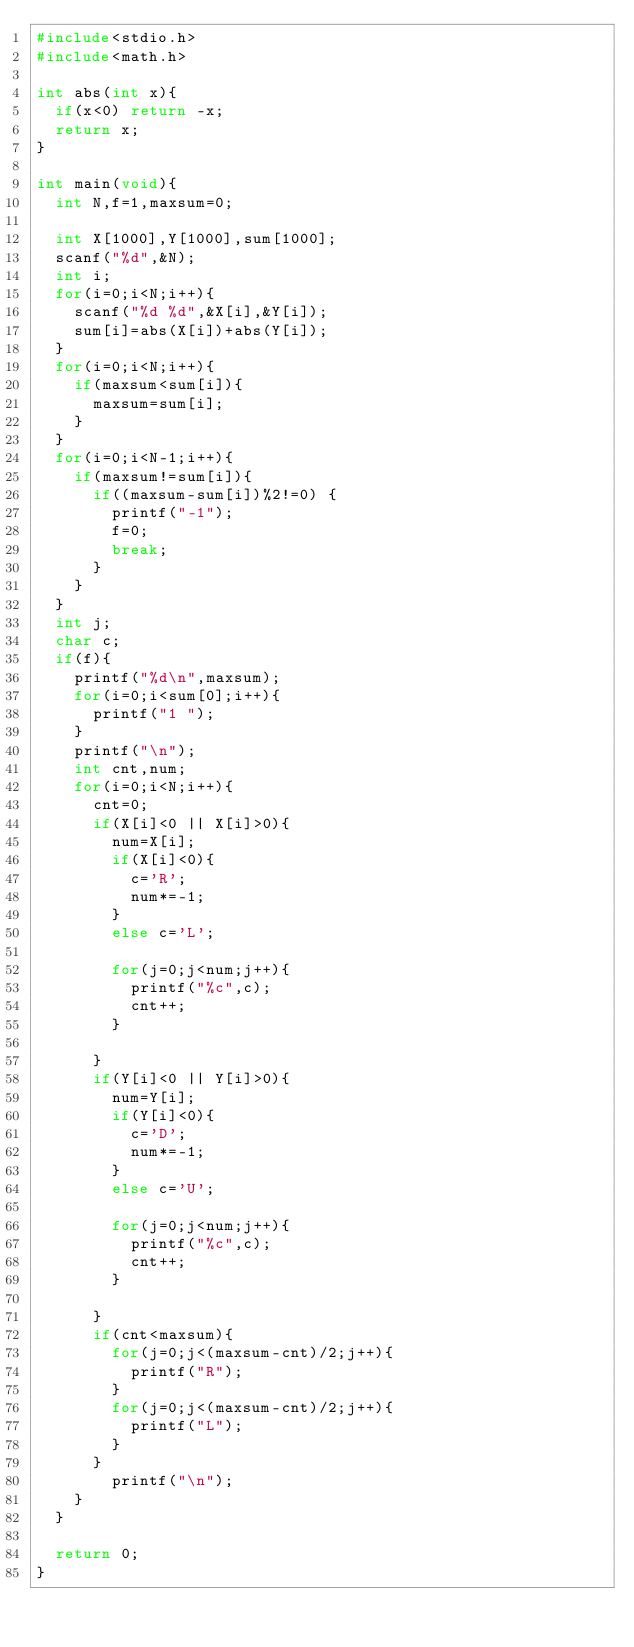<code> <loc_0><loc_0><loc_500><loc_500><_C_>#include<stdio.h>
#include<math.h>

int abs(int x){
  if(x<0) return -x;
  return x;
}

int main(void){
  int N,f=1,maxsum=0;

  int X[1000],Y[1000],sum[1000];
  scanf("%d",&N);
  int i;
  for(i=0;i<N;i++){
    scanf("%d %d",&X[i],&Y[i]);
    sum[i]=abs(X[i])+abs(Y[i]);
  }
  for(i=0;i<N;i++){
    if(maxsum<sum[i]){
      maxsum=sum[i];
    }
  }
  for(i=0;i<N-1;i++){
    if(maxsum!=sum[i]){
      if((maxsum-sum[i])%2!=0) {
        printf("-1");
        f=0;
        break;
      }
    }
  }
  int j;
  char c;
  if(f){
    printf("%d\n",maxsum);
    for(i=0;i<sum[0];i++){
      printf("1 ");
    }
    printf("\n");
    int cnt,num;
    for(i=0;i<N;i++){
      cnt=0;
      if(X[i]<0 || X[i]>0){
        num=X[i];
        if(X[i]<0){
          c='R';
          num*=-1;
        }
        else c='L';

        for(j=0;j<num;j++){
          printf("%c",c);
          cnt++;
        }

      }
      if(Y[i]<0 || Y[i]>0){
        num=Y[i];
        if(Y[i]<0){
          c='D';
          num*=-1;
        }
        else c='U';

        for(j=0;j<num;j++){
          printf("%c",c);
          cnt++;
        }

      }
      if(cnt<maxsum){
        for(j=0;j<(maxsum-cnt)/2;j++){
          printf("R");
        }
        for(j=0;j<(maxsum-cnt)/2;j++){
          printf("L");
        }
      }
        printf("\n");
    }
  }

  return 0;
}
</code> 